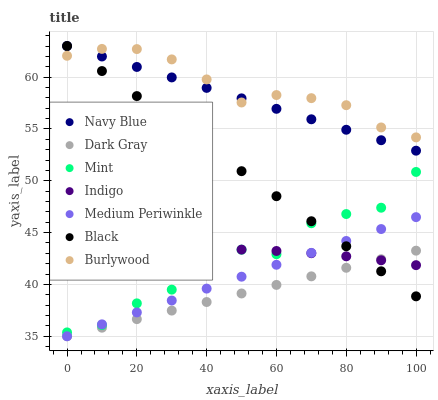Does Dark Gray have the minimum area under the curve?
Answer yes or no. Yes. Does Burlywood have the maximum area under the curve?
Answer yes or no. Yes. Does Navy Blue have the minimum area under the curve?
Answer yes or no. No. Does Navy Blue have the maximum area under the curve?
Answer yes or no. No. Is Navy Blue the smoothest?
Answer yes or no. Yes. Is Mint the roughest?
Answer yes or no. Yes. Is Burlywood the smoothest?
Answer yes or no. No. Is Burlywood the roughest?
Answer yes or no. No. Does Medium Periwinkle have the lowest value?
Answer yes or no. Yes. Does Navy Blue have the lowest value?
Answer yes or no. No. Does Black have the highest value?
Answer yes or no. Yes. Does Burlywood have the highest value?
Answer yes or no. No. Is Medium Periwinkle less than Burlywood?
Answer yes or no. Yes. Is Navy Blue greater than Indigo?
Answer yes or no. Yes. Does Burlywood intersect Black?
Answer yes or no. Yes. Is Burlywood less than Black?
Answer yes or no. No. Is Burlywood greater than Black?
Answer yes or no. No. Does Medium Periwinkle intersect Burlywood?
Answer yes or no. No. 